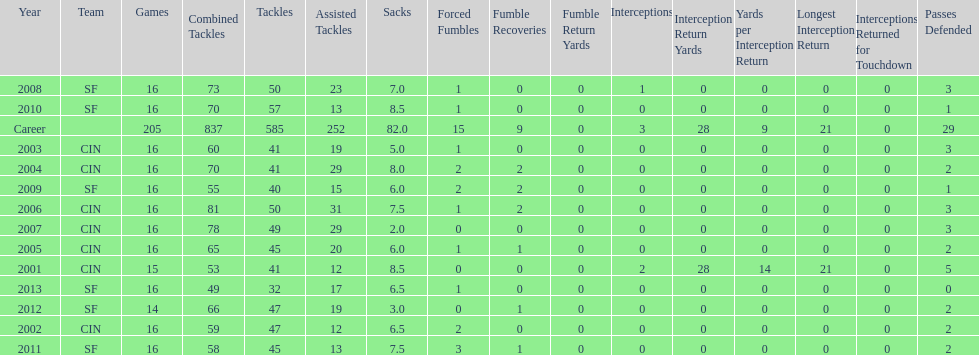In his first five seasons, how many sacks did this player accomplish? 34. 